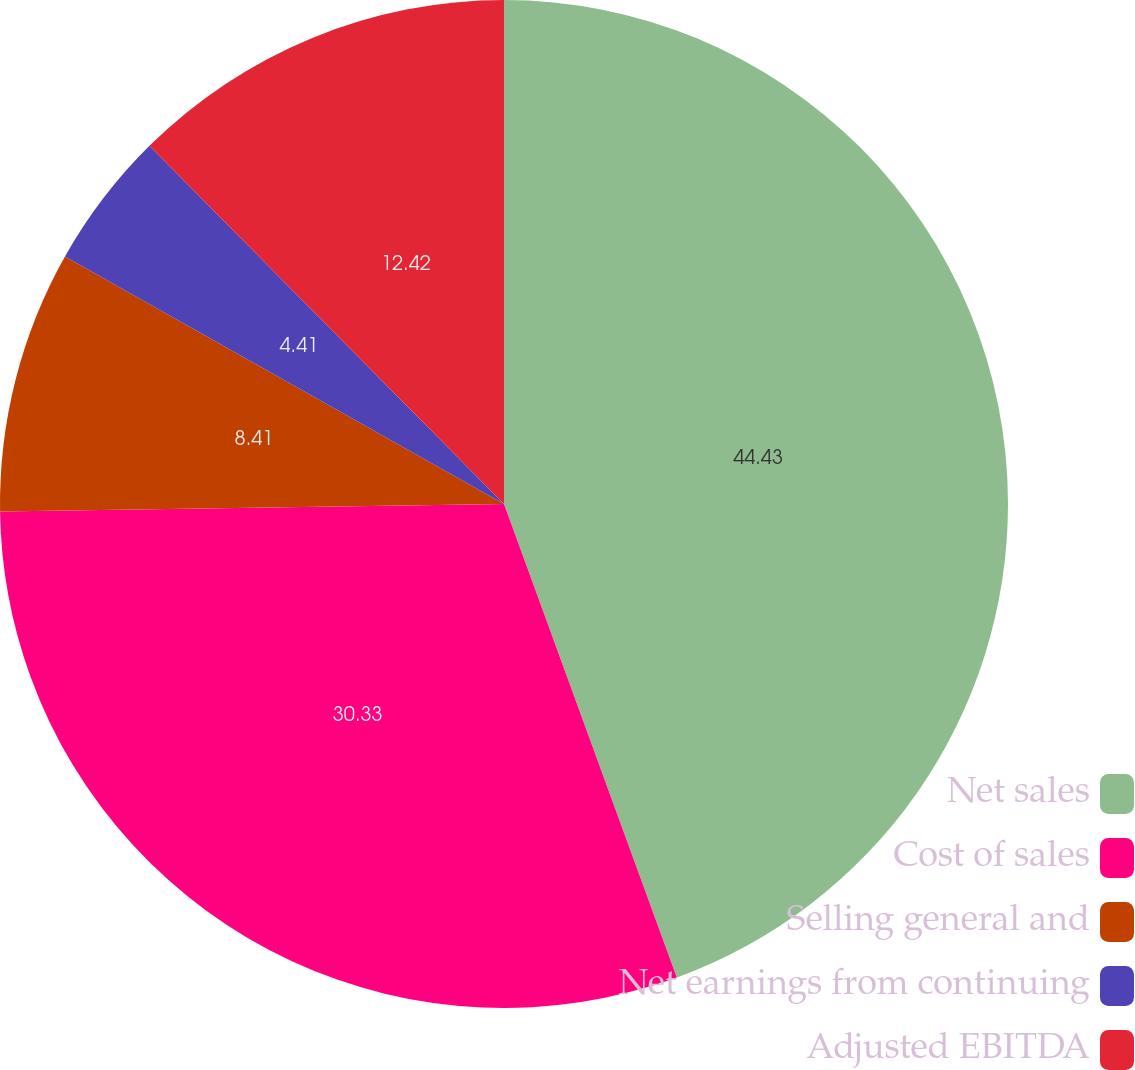<chart> <loc_0><loc_0><loc_500><loc_500><pie_chart><fcel>Net sales<fcel>Cost of sales<fcel>Selling general and<fcel>Net earnings from continuing<fcel>Adjusted EBITDA<nl><fcel>44.43%<fcel>30.33%<fcel>8.41%<fcel>4.41%<fcel>12.42%<nl></chart> 